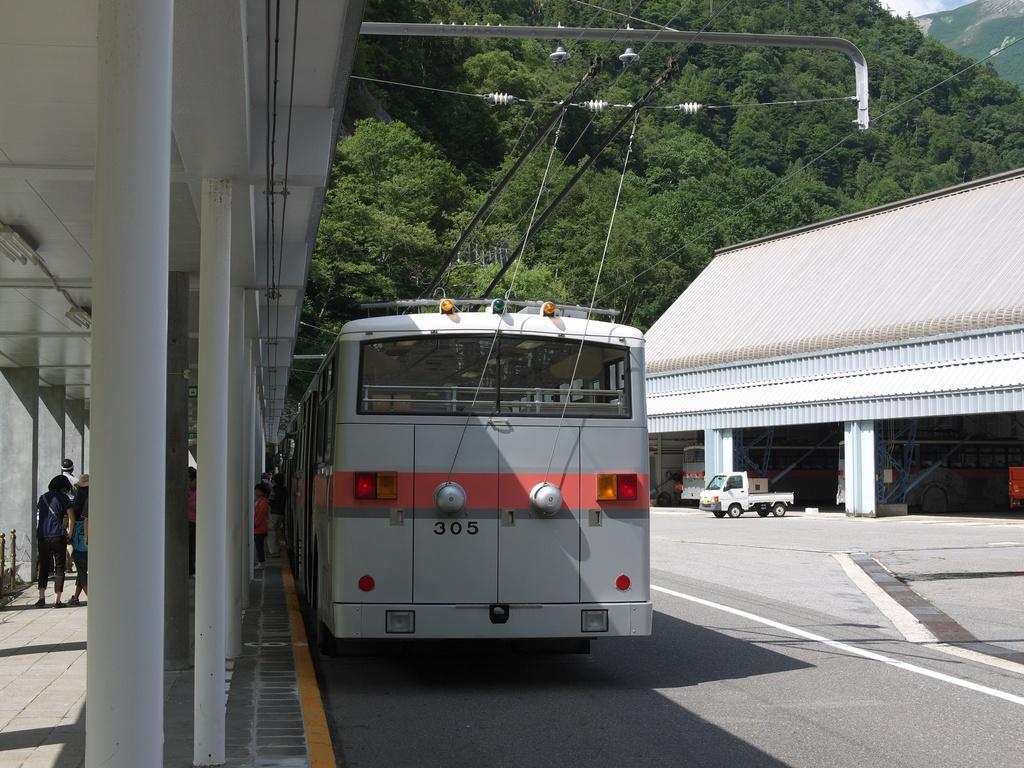Please provide a concise description of this image. In the picture we can see a road on it, we can see a bus at the top of it, we can see some wire connections and beside it, we can see a shed with some poles and pillars to it and under it we can see some people are standing and opposite to it, we can see a shed and near it we can see some vehicle and in the background we can see a hill with full of trees. 